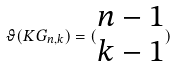Convert formula to latex. <formula><loc_0><loc_0><loc_500><loc_500>\vartheta ( K G _ { n , k } ) = ( \begin{matrix} n - 1 \\ k - 1 \end{matrix} )</formula> 